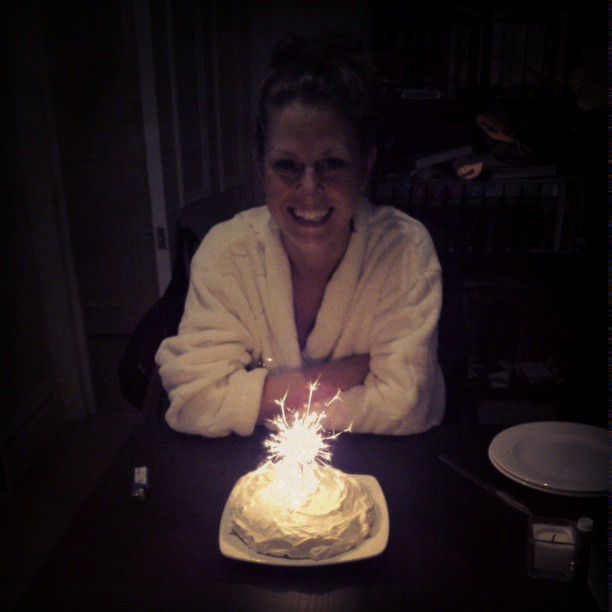How old is the birthday person? Determining the exact age from the image is challenging, however, visual cues such as general appearance and context suggest she might be in her late 30s or early 40s. 